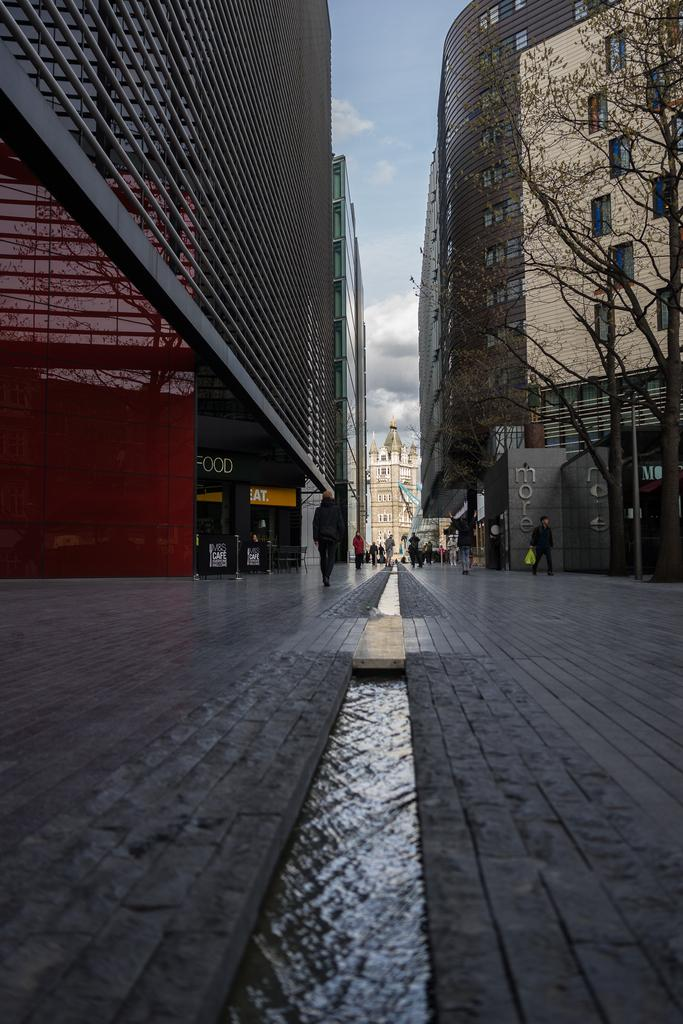Provide a one-sentence caption for the provided image. A narrow, brick city street that runs between two high rises has a stream of water running down its middle. 